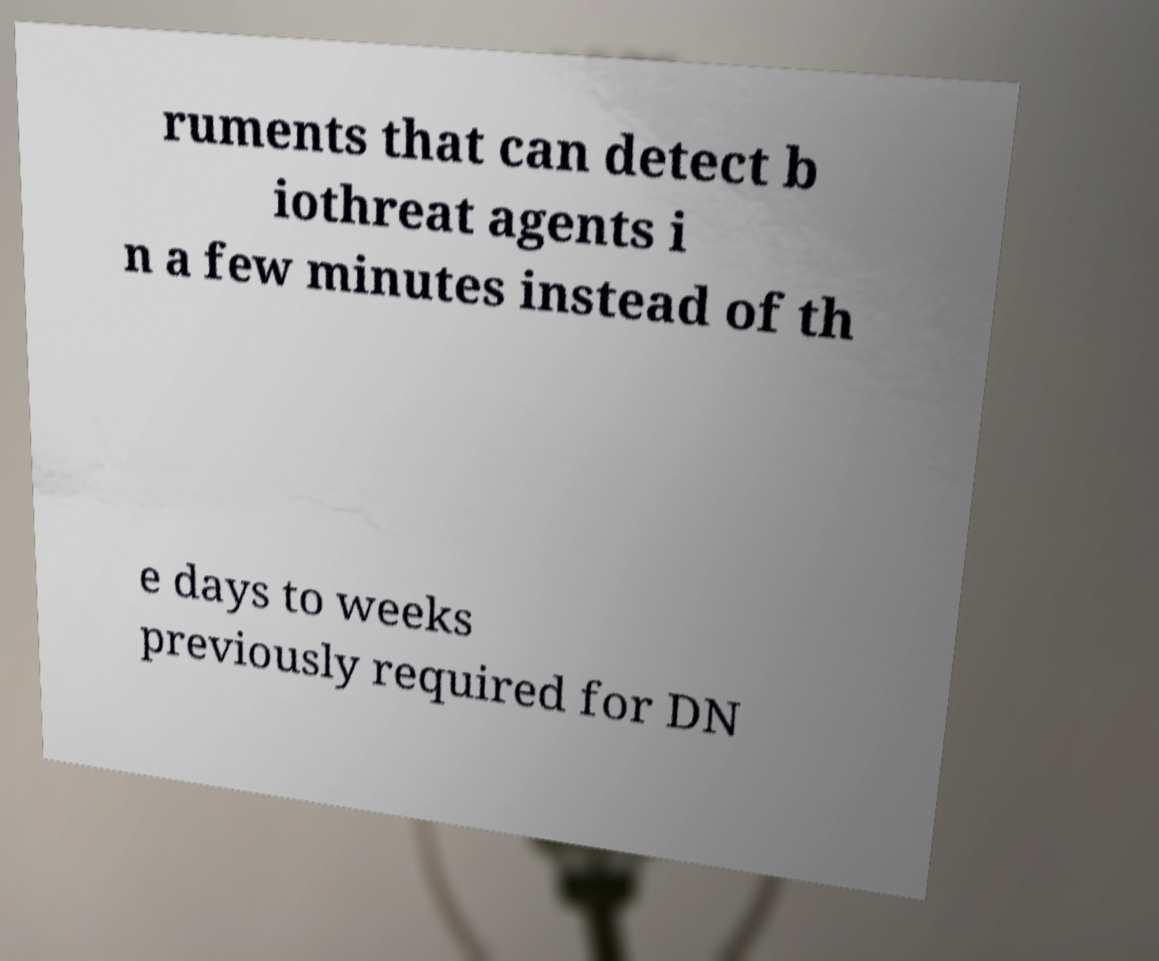There's text embedded in this image that I need extracted. Can you transcribe it verbatim? ruments that can detect b iothreat agents i n a few minutes instead of th e days to weeks previously required for DN 